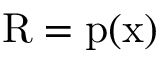Convert formula to latex. <formula><loc_0><loc_0><loc_500><loc_500>{ R } = { p ( x ) }</formula> 